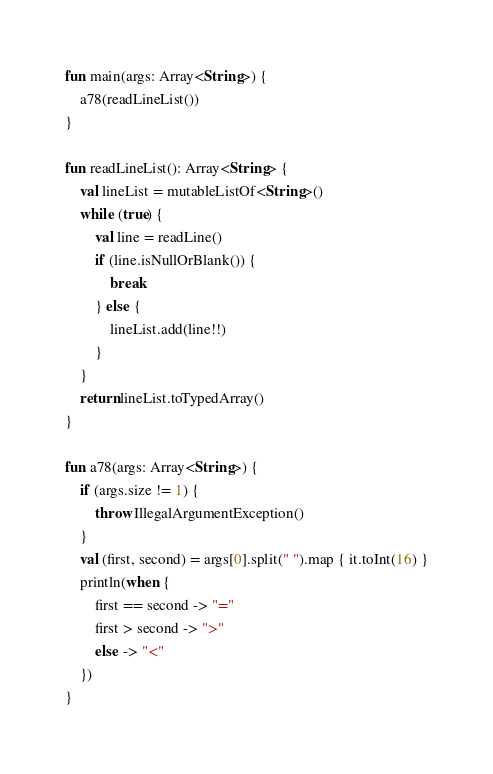<code> <loc_0><loc_0><loc_500><loc_500><_Kotlin_>fun main(args: Array<String>) {
    a78(readLineList())
}

fun readLineList(): Array<String> {
    val lineList = mutableListOf<String>()
    while (true) {
        val line = readLine()
        if (line.isNullOrBlank()) {
            break
        } else {
            lineList.add(line!!)
        }
    }
    return lineList.toTypedArray()
}

fun a78(args: Array<String>) {
    if (args.size != 1) {
        throw IllegalArgumentException()
    }
    val (first, second) = args[0].split(" ").map { it.toInt(16) }
    println(when {
        first == second -> "="
        first > second -> ">"
        else -> "<"
    })
}</code> 